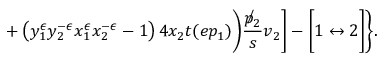Convert formula to latex. <formula><loc_0><loc_0><loc_500><loc_500>+ \left ( y _ { 1 } ^ { \epsilon } y _ { 2 } ^ { - \epsilon } x _ { 1 } ^ { \epsilon } x _ { 2 } ^ { - \epsilon } - 1 \right ) 4 x _ { 2 } t ( e p _ { 1 } ) \Big ) \frac { \not p _ { 2 } } { s } v _ { 2 } \Big ] - \Big [ 1 \leftrightarrow 2 \Big ] \Big \} .</formula> 